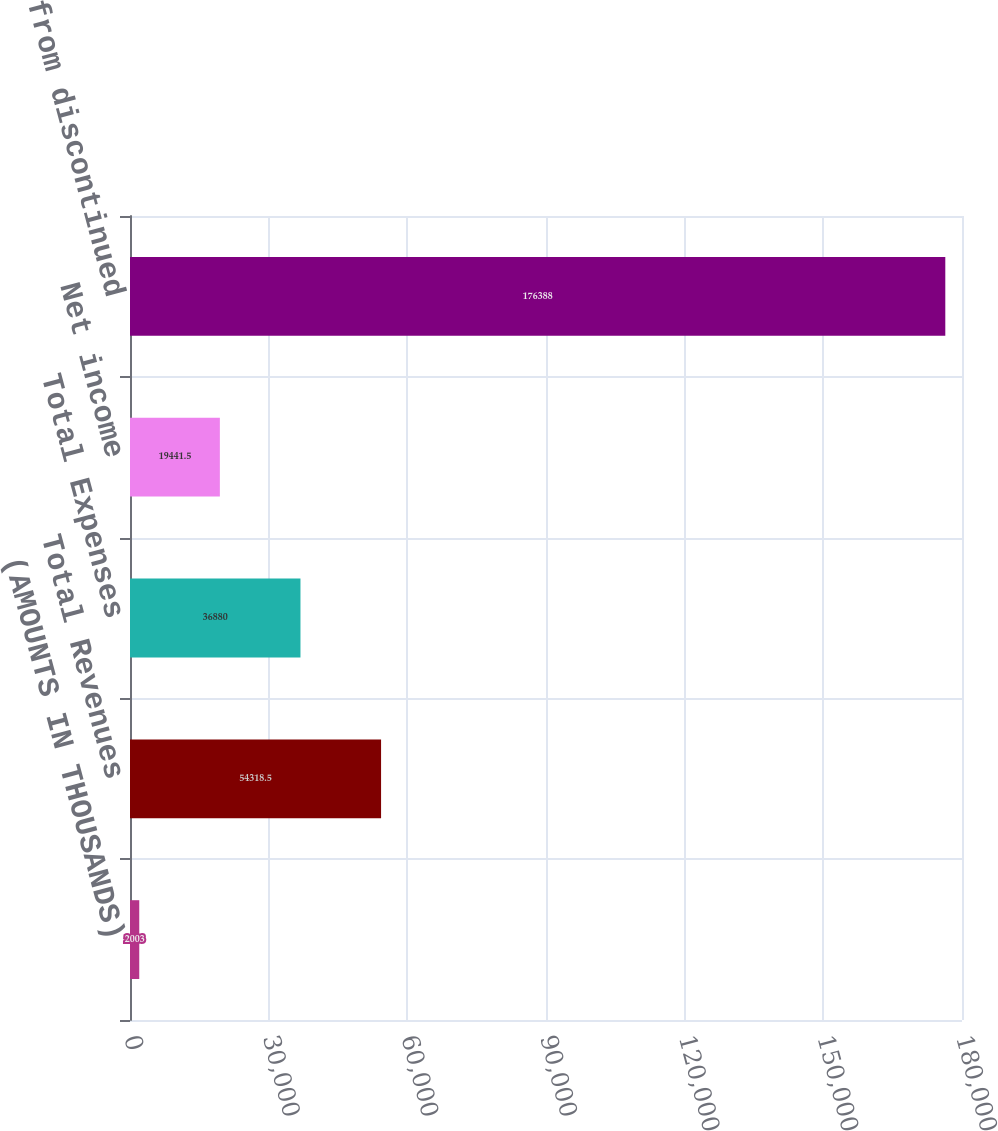<chart> <loc_0><loc_0><loc_500><loc_500><bar_chart><fcel>(AMOUNTS IN THOUSANDS)<fcel>Total Revenues<fcel>Total Expenses<fcel>Net income<fcel>Income from discontinued<nl><fcel>2003<fcel>54318.5<fcel>36880<fcel>19441.5<fcel>176388<nl></chart> 